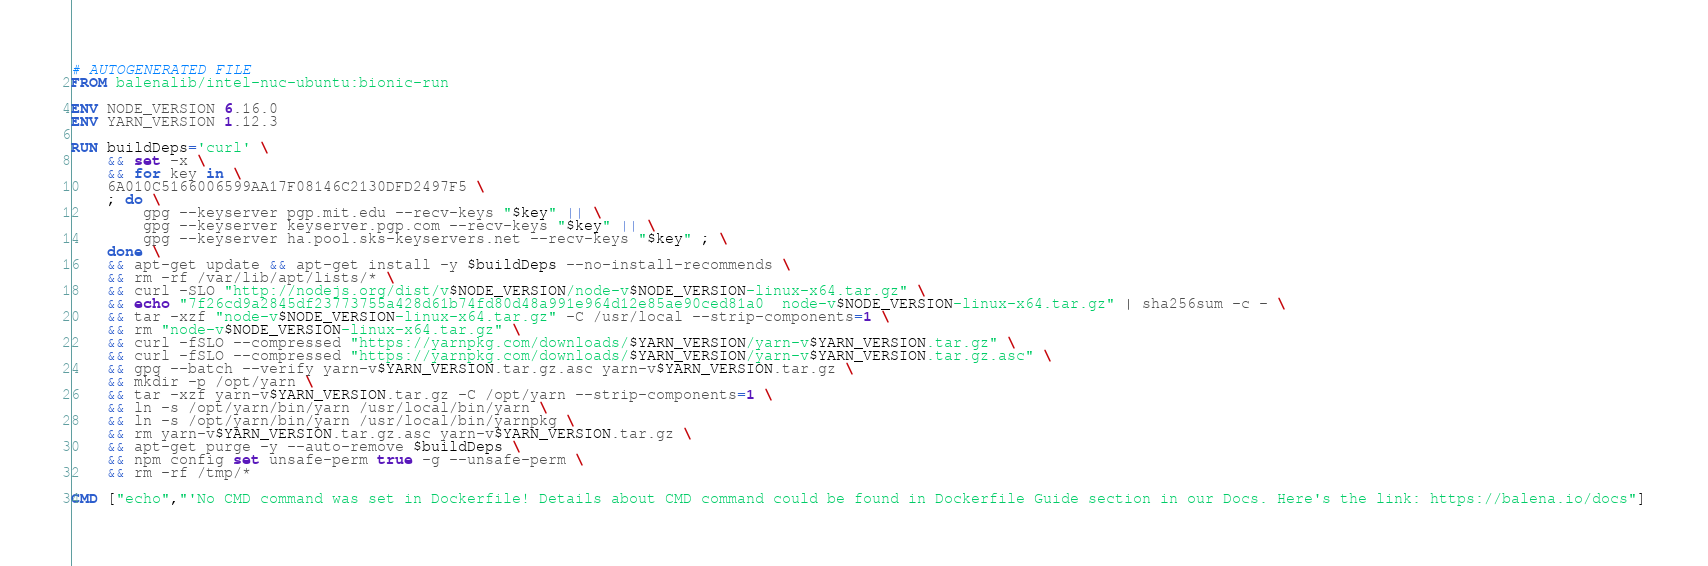<code> <loc_0><loc_0><loc_500><loc_500><_Dockerfile_># AUTOGENERATED FILE
FROM balenalib/intel-nuc-ubuntu:bionic-run

ENV NODE_VERSION 6.16.0
ENV YARN_VERSION 1.12.3

RUN buildDeps='curl' \
	&& set -x \
	&& for key in \
	6A010C5166006599AA17F08146C2130DFD2497F5 \
	; do \
		gpg --keyserver pgp.mit.edu --recv-keys "$key" || \
		gpg --keyserver keyserver.pgp.com --recv-keys "$key" || \
		gpg --keyserver ha.pool.sks-keyservers.net --recv-keys "$key" ; \
	done \
	&& apt-get update && apt-get install -y $buildDeps --no-install-recommends \
	&& rm -rf /var/lib/apt/lists/* \
	&& curl -SLO "http://nodejs.org/dist/v$NODE_VERSION/node-v$NODE_VERSION-linux-x64.tar.gz" \
	&& echo "7f26cd9a2845df23773755a428d61b74fd80d48a991e964d12e85ae90ced81a0  node-v$NODE_VERSION-linux-x64.tar.gz" | sha256sum -c - \
	&& tar -xzf "node-v$NODE_VERSION-linux-x64.tar.gz" -C /usr/local --strip-components=1 \
	&& rm "node-v$NODE_VERSION-linux-x64.tar.gz" \
	&& curl -fSLO --compressed "https://yarnpkg.com/downloads/$YARN_VERSION/yarn-v$YARN_VERSION.tar.gz" \
	&& curl -fSLO --compressed "https://yarnpkg.com/downloads/$YARN_VERSION/yarn-v$YARN_VERSION.tar.gz.asc" \
	&& gpg --batch --verify yarn-v$YARN_VERSION.tar.gz.asc yarn-v$YARN_VERSION.tar.gz \
	&& mkdir -p /opt/yarn \
	&& tar -xzf yarn-v$YARN_VERSION.tar.gz -C /opt/yarn --strip-components=1 \
	&& ln -s /opt/yarn/bin/yarn /usr/local/bin/yarn \
	&& ln -s /opt/yarn/bin/yarn /usr/local/bin/yarnpkg \
	&& rm yarn-v$YARN_VERSION.tar.gz.asc yarn-v$YARN_VERSION.tar.gz \
	&& apt-get purge -y --auto-remove $buildDeps \
	&& npm config set unsafe-perm true -g --unsafe-perm \
	&& rm -rf /tmp/*

CMD ["echo","'No CMD command was set in Dockerfile! Details about CMD command could be found in Dockerfile Guide section in our Docs. Here's the link: https://balena.io/docs"]</code> 